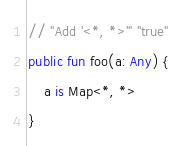<code> <loc_0><loc_0><loc_500><loc_500><_Kotlin_>// "Add '<*, *>'" "true"
public fun foo(a: Any) {
    a is Map<*, *>
}</code> 